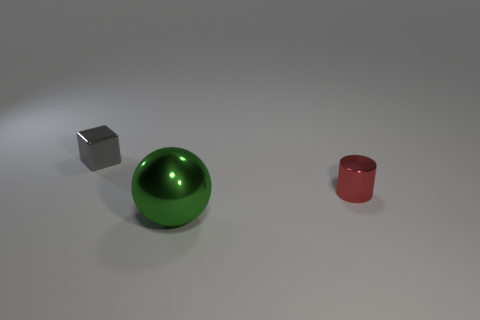Can you describe the lighting in the image and its effect on the objects? The lighting in the image appears to be coming from above and is soft, creating gentle shadows beneath each object. This type of lighting accentuates the shapes and textures of the objects, with the shiny surfaces reflecting the light, which highlights their material properties and contributes to the overall three-dimensional effect of the scene.  Is the reflection on the sphere indicative of a certain type of environment outside the image frame? Although the environment outside the image frame isn't directly visible, the reflection on the shiny green sphere suggests an environment with a diffuse light source, such as a softbox or overcast sky. This type of indirect lighting creates a smooth and even reflection on the sphere's surface. 